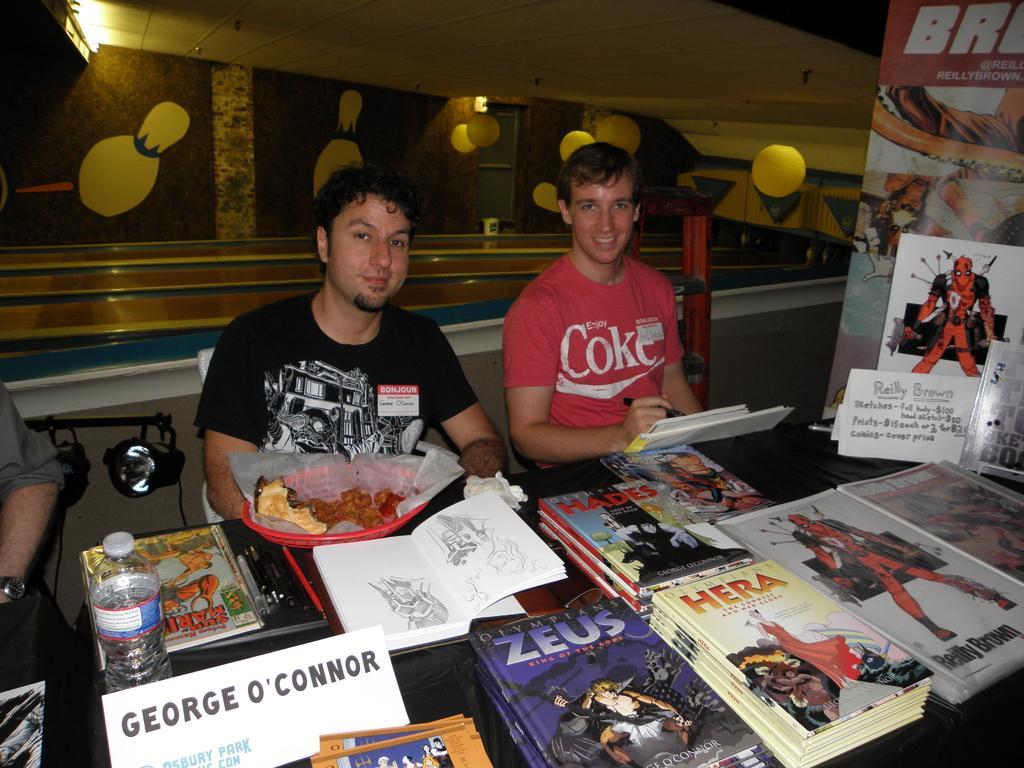Can you describe this image briefly? In this image we can see two men are sitting. One man is wearing a red color T-shirt and holding a marker in his hand. The other man is wearing a black color T-shirt. In front of them, we can see a table. On the table, there are so many books, posters, bottle, papers and food item is present. There is a banner on the right side of the image. We can see a light and a person on the left side of the image. In the background, we can see railing, wall, light and the roof. We can see yellow color balls are hung from the roof. 